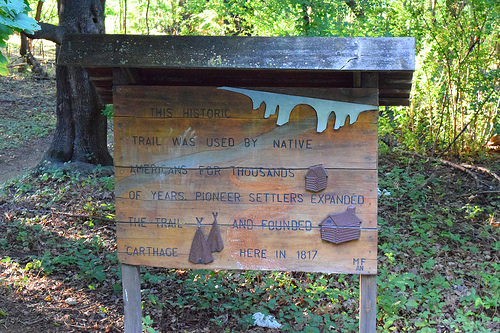<image>
Is the tree to the right of the sign? No. The tree is not to the right of the sign. The horizontal positioning shows a different relationship. 